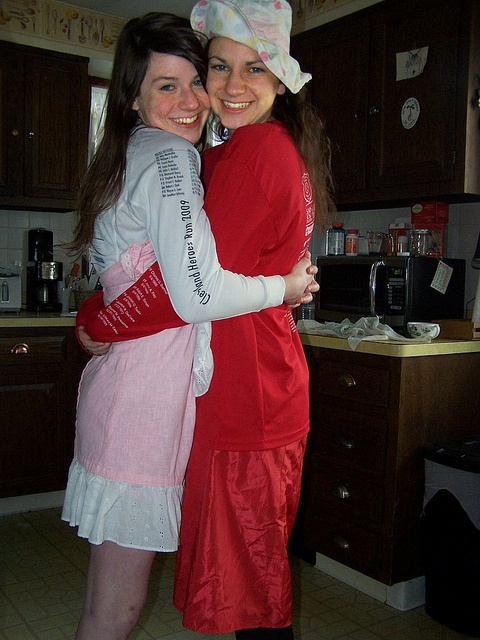Describe the objects in this image and their specific colors. I can see people in black, brown, maroon, and darkgray tones, people in black, darkgray, gray, and brown tones, microwave in black, gray, and darkgray tones, bottle in black, purple, maroon, and darkgray tones, and cup in black, gray, and darkgray tones in this image. 